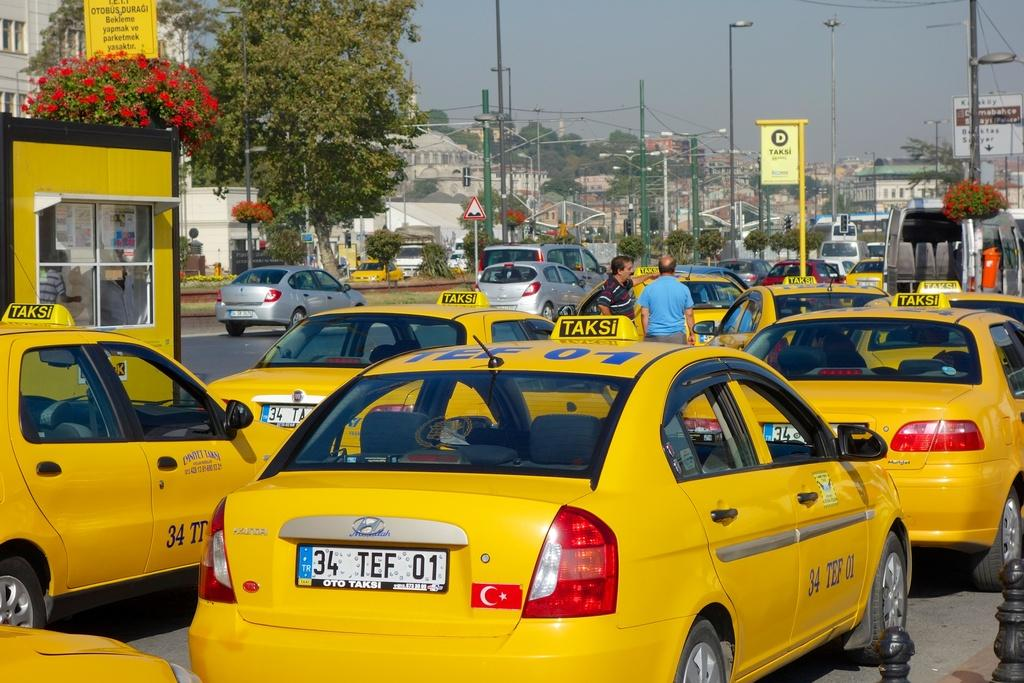<image>
Give a short and clear explanation of the subsequent image. A yellow taxi with the license plate 34 TEF 01 waiting in traffic. 